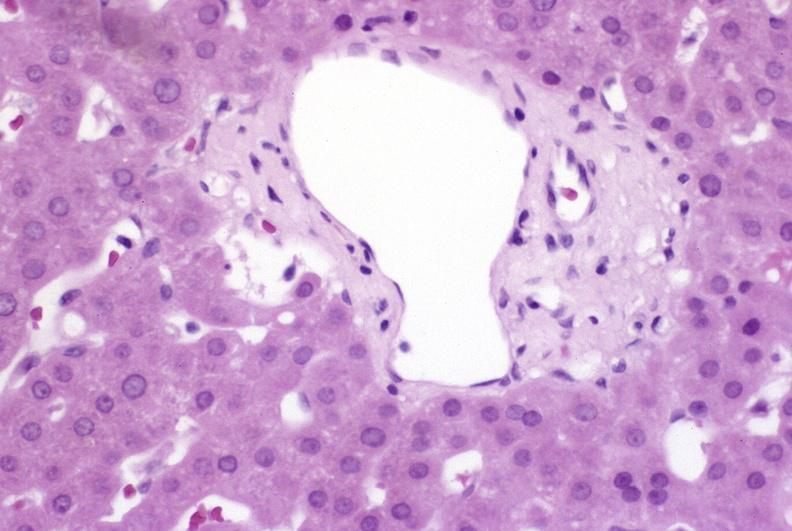s plasma cell present?
Answer the question using a single word or phrase. No 